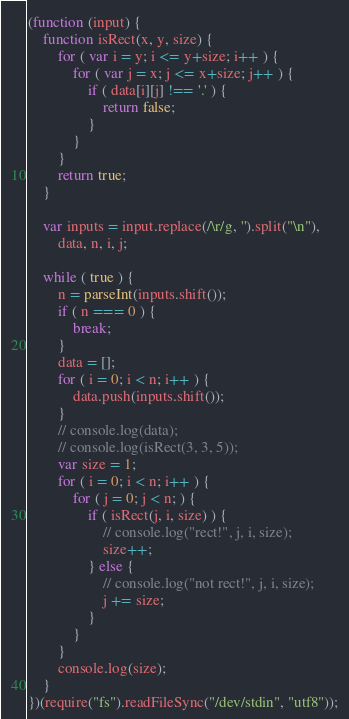<code> <loc_0><loc_0><loc_500><loc_500><_JavaScript_>(function (input) {
    function isRect(x, y, size) {
        for ( var i = y; i <= y+size; i++ ) {
            for ( var j = x; j <= x+size; j++ ) {
                if ( data[i][j] !== '.' ) {
                    return false;
                }
            }
        }
        return true;
    }

    var inputs = input.replace(/\r/g, '').split("\n"),
        data, n, i, j;

    while ( true ) {
        n = parseInt(inputs.shift());
        if ( n === 0 ) {
            break;
        }
        data = [];
        for ( i = 0; i < n; i++ ) {
            data.push(inputs.shift());
        }
        // console.log(data);
        // console.log(isRect(3, 3, 5));
        var size = 1;
        for ( i = 0; i < n; i++ ) {
            for ( j = 0; j < n; ) {
                if ( isRect(j, i, size) ) {
                    // console.log("rect!", j, i, size);
                    size++;
                } else {
                    // console.log("not rect!", j, i, size);
                    j += size;
                }
            }
        }
        console.log(size);
    }
})(require("fs").readFileSync("/dev/stdin", "utf8"));</code> 